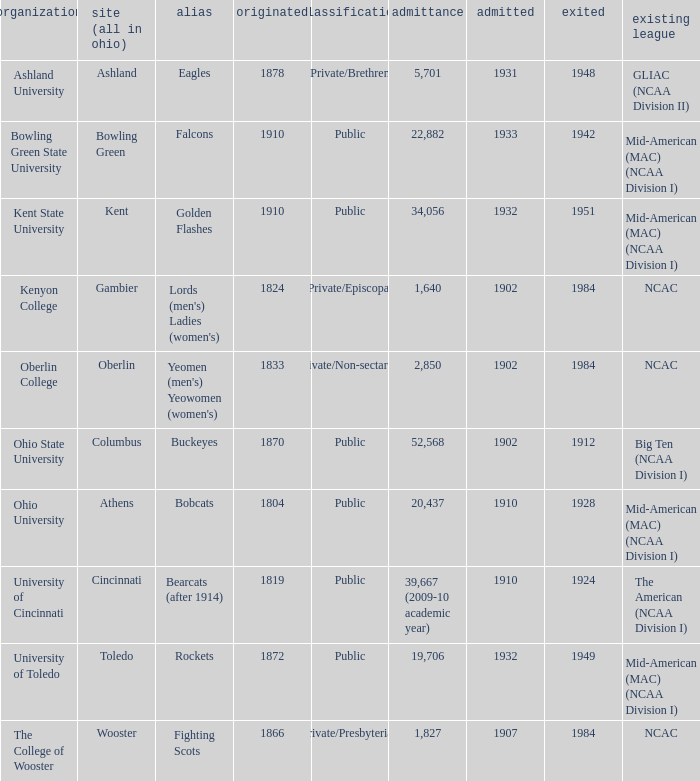What is the type of institution in Kent State University? Public. 